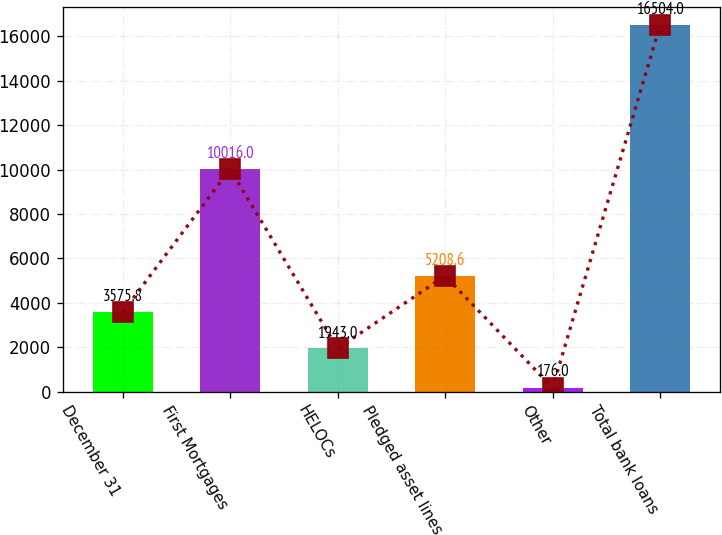<chart> <loc_0><loc_0><loc_500><loc_500><bar_chart><fcel>December 31<fcel>First Mortgages<fcel>HELOCs<fcel>Pledged asset lines<fcel>Other<fcel>Total bank loans<nl><fcel>3575.8<fcel>10016<fcel>1943<fcel>5208.6<fcel>176<fcel>16504<nl></chart> 